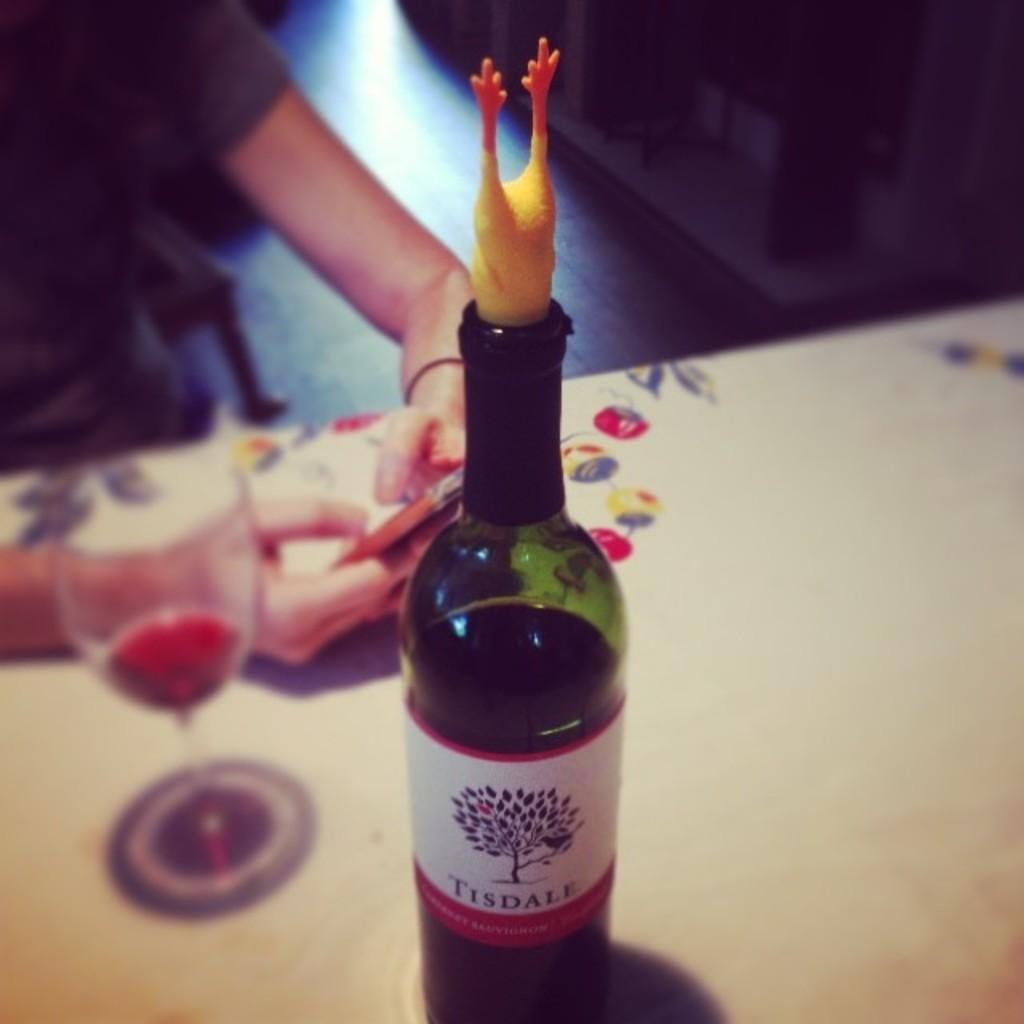<image>
Share a concise interpretation of the image provided. A bottle of Tisdale Cabernet Sauvignon is on a table near a person with a cell phone. 